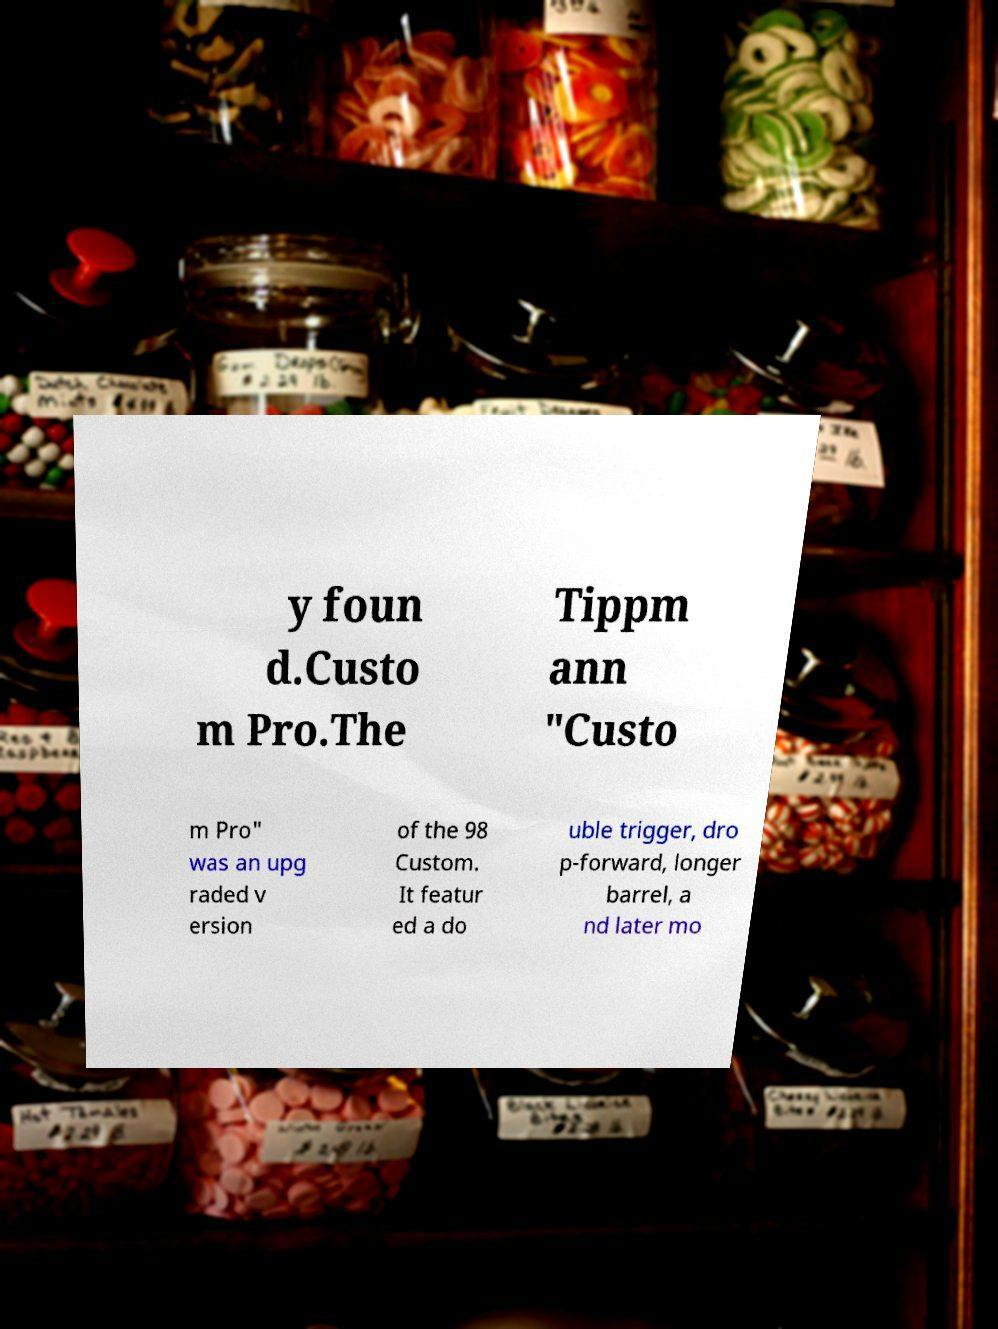I need the written content from this picture converted into text. Can you do that? y foun d.Custo m Pro.The Tippm ann "Custo m Pro" was an upg raded v ersion of the 98 Custom. It featur ed a do uble trigger, dro p-forward, longer barrel, a nd later mo 